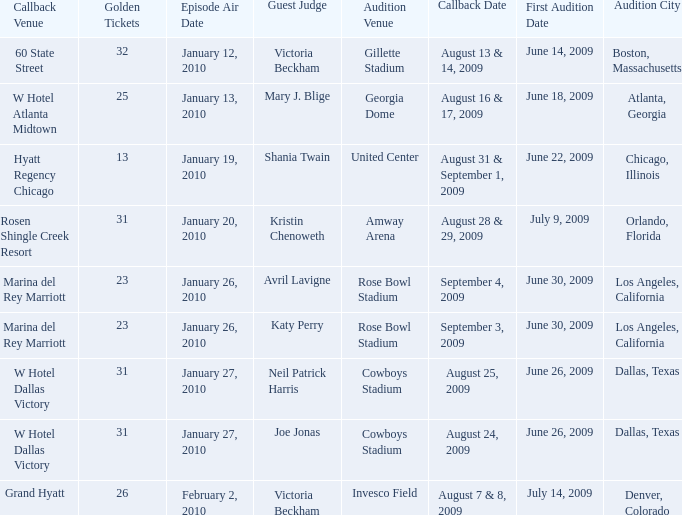Name the audition city for hyatt regency chicago Chicago, Illinois. 